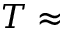Convert formula to latex. <formula><loc_0><loc_0><loc_500><loc_500>T \approx</formula> 